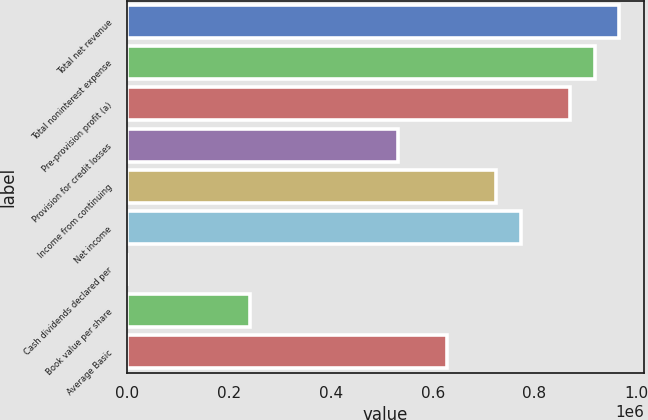<chart> <loc_0><loc_0><loc_500><loc_500><bar_chart><fcel>Total net revenue<fcel>Total noninterest expense<fcel>Pre-provision profit (a)<fcel>Provision for credit losses<fcel>Income from continuing<fcel>Net income<fcel>Cash dividends declared per<fcel>Book value per share<fcel>Average Basic<nl><fcel>966253<fcel>917940<fcel>869627<fcel>531440<fcel>724690<fcel>773002<fcel>1.36<fcel>241564<fcel>628065<nl></chart> 